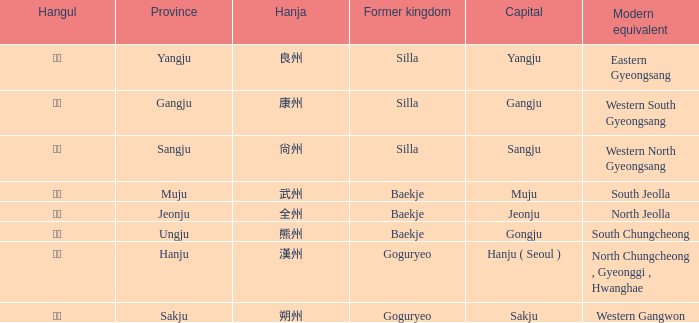The hanja 尙州 is for what capital? Sangju. 